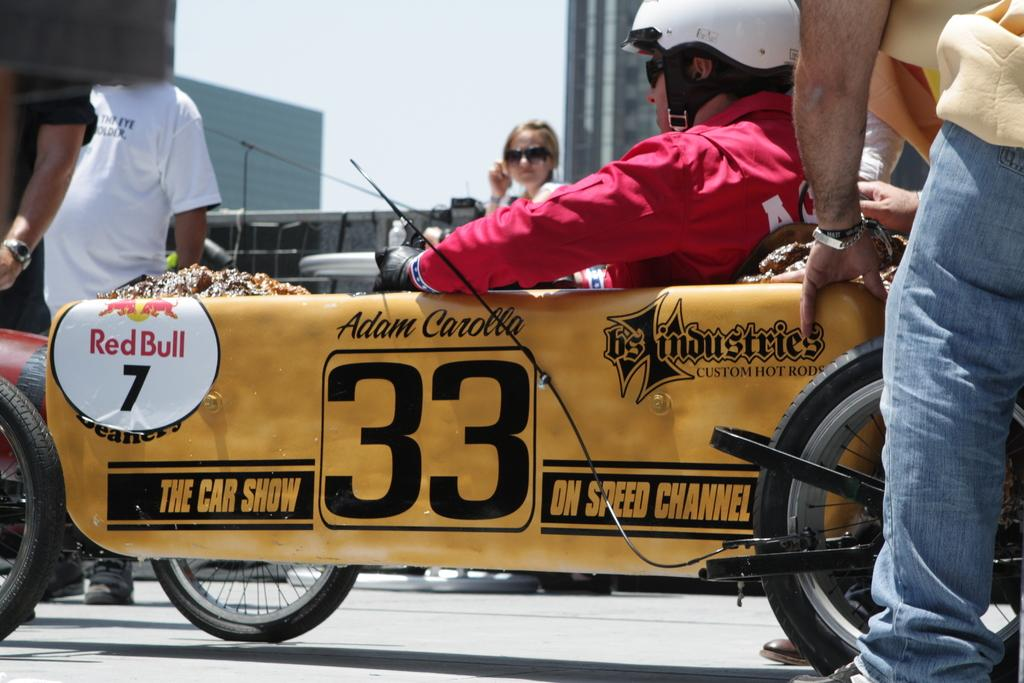What is visible at the top of the image? The sky is visible at the top of the image. What type of structures can be seen in the image? There are buildings in the image. What are the persons in the image doing? A: There are persons sitting on a vehicle and standing on the road in the image. What is the nature of the surface on which the persons are standing? There is a road in the image, which is the surface on which the persons are standing. What type of respect can be seen being given to the zephyr in the image? There is no zephyr present in the image, and therefore no such interaction can be observed. What class of vehicle are the persons sitting on in the image? The type of vehicle is not specified in the image, so it cannot be determined which class it belongs to. 